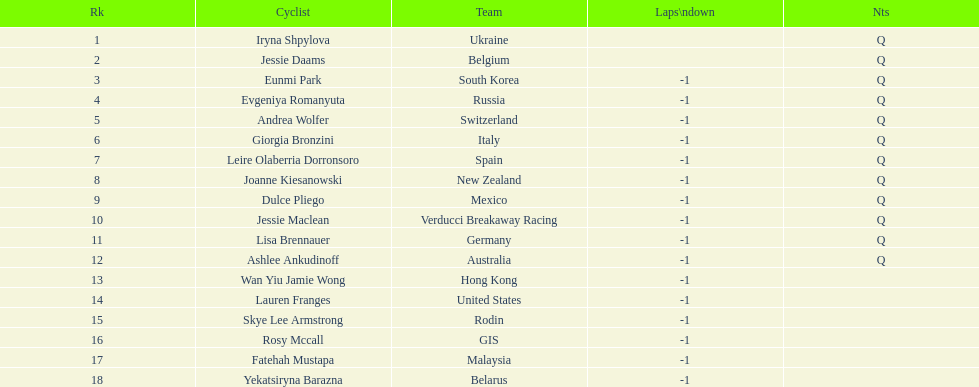Who was the competitor that finished above jessie maclean? Dulce Pliego. 